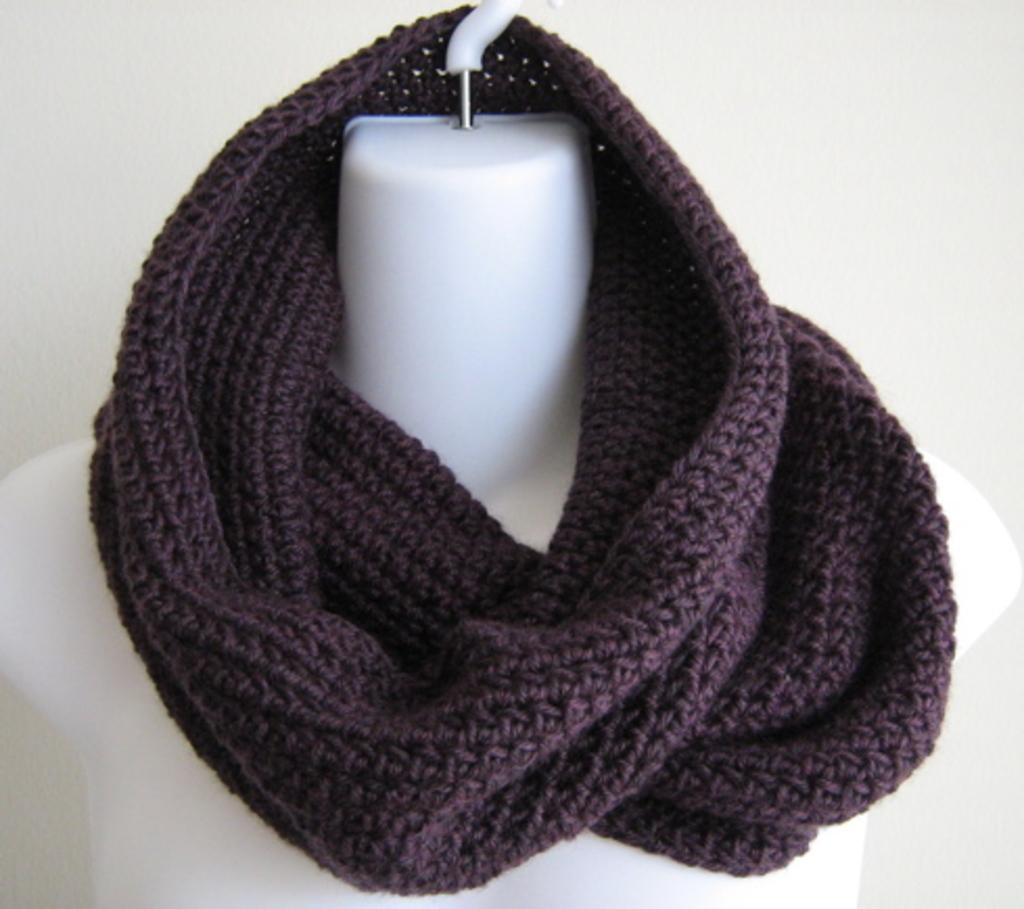What is present on the mannequin in the image? There is a stole in the image. How is the stole positioned in the image? The stole is hanged on a mannequin. What type of berry can be seen growing on the mannequin in the image? There are no berries present on the mannequin in the image. What is the texture of the chin of the mannequin in the image? The image does not provide information about the texture of the mannequin's chin. 